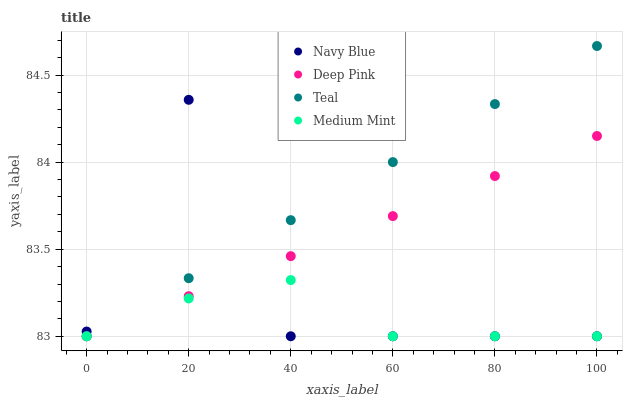Does Medium Mint have the minimum area under the curve?
Answer yes or no. Yes. Does Teal have the maximum area under the curve?
Answer yes or no. Yes. Does Navy Blue have the minimum area under the curve?
Answer yes or no. No. Does Navy Blue have the maximum area under the curve?
Answer yes or no. No. Is Deep Pink the smoothest?
Answer yes or no. Yes. Is Navy Blue the roughest?
Answer yes or no. Yes. Is Navy Blue the smoothest?
Answer yes or no. No. Is Deep Pink the roughest?
Answer yes or no. No. Does Medium Mint have the lowest value?
Answer yes or no. Yes. Does Teal have the highest value?
Answer yes or no. Yes. Does Navy Blue have the highest value?
Answer yes or no. No. Does Navy Blue intersect Teal?
Answer yes or no. Yes. Is Navy Blue less than Teal?
Answer yes or no. No. Is Navy Blue greater than Teal?
Answer yes or no. No. 